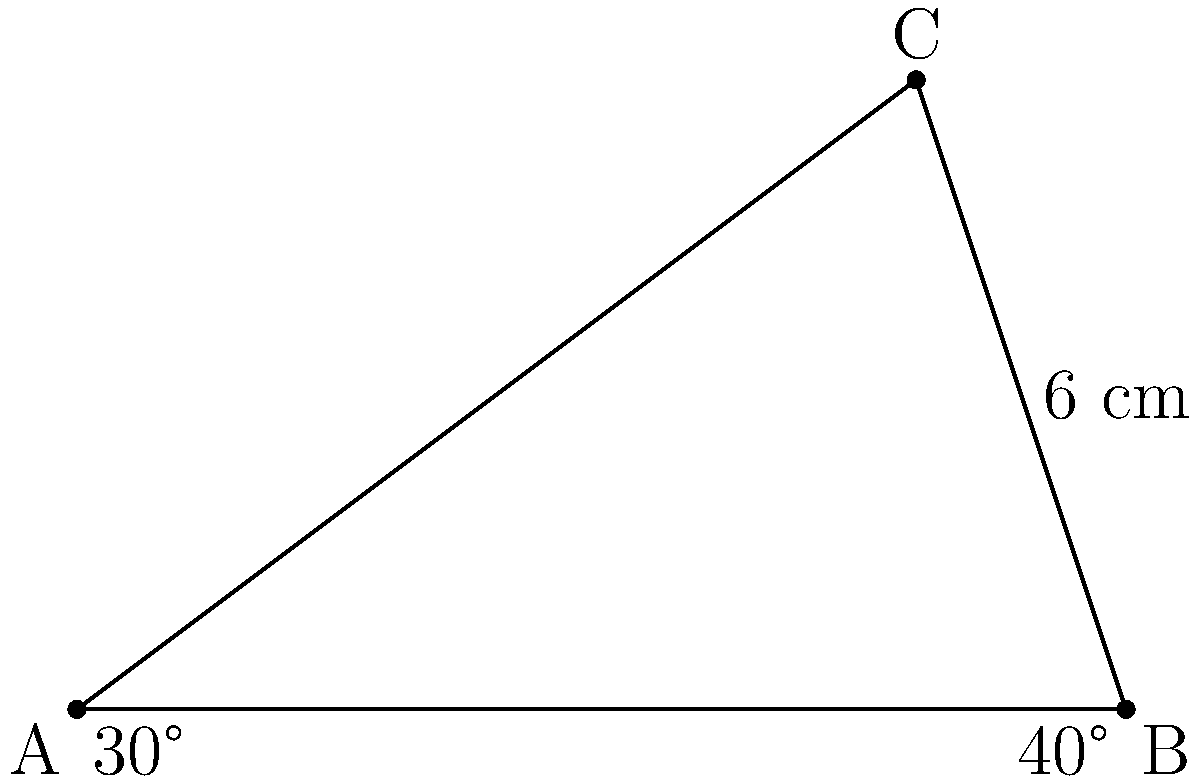In the cultural district, you're standing at point A observing two iconic buildings at points B and C. The angle between your line of sight to building B and the ground is 30°, while the angle between your line of sight to building C and the ground is 70°. The distance between buildings B and C is 6 cm on your city map. Using trigonometry, calculate the actual distance between you (point A) and building B (point B) in meters, given that 1 cm on the map represents 50 meters in reality. Let's approach this step-by-step:

1) First, we need to find the angles in the triangle ABC:
   - Angle BAC = 30°
   - Angle ABC = 40° (since 70° - 30° = 40°)
   - Angle BCA = 110° (since the sum of angles in a triangle is 180°)

2) We know the length of BC on the map is 6 cm. Let's call the actual length of AB (what we're looking for) x meters.

3) We can use the sine law:
   $$\frac{BC}{\sin(BAC)} = \frac{AB}{\sin(BCA)}$$

4) Substituting our known values:
   $$\frac{6}{\sin(30°)} = \frac{x/50}{\sin(110°)}$$

5) Solving for x:
   $$x = \frac{6 \cdot 50 \cdot \sin(110°)}{\sin(30°)}$$

6) Now, let's calculate:
   $$x = \frac{6 \cdot 50 \cdot 0.9397}{0.5} = 563.82$$

Therefore, the actual distance between you (A) and building B is approximately 563.82 meters.
Answer: 563.82 meters 